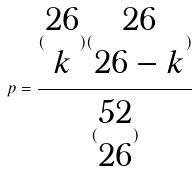<formula> <loc_0><loc_0><loc_500><loc_500>p = \frac { ( \begin{matrix} 2 6 \\ k \end{matrix} ) ( \begin{matrix} 2 6 \\ 2 6 - k \end{matrix} ) } { ( \begin{matrix} 5 2 \\ 2 6 \end{matrix} ) }</formula> 